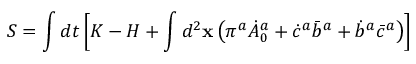Convert formula to latex. <formula><loc_0><loc_0><loc_500><loc_500>S = \int d t \left [ K - H + \int d ^ { 2 } { x } \left ( \pi ^ { a } \dot { A } _ { 0 } ^ { a } + \dot { c } ^ { a } { \bar { b } } ^ { a } + \dot { b } ^ { a } \bar { c } ^ { a } \right ) \right ]</formula> 